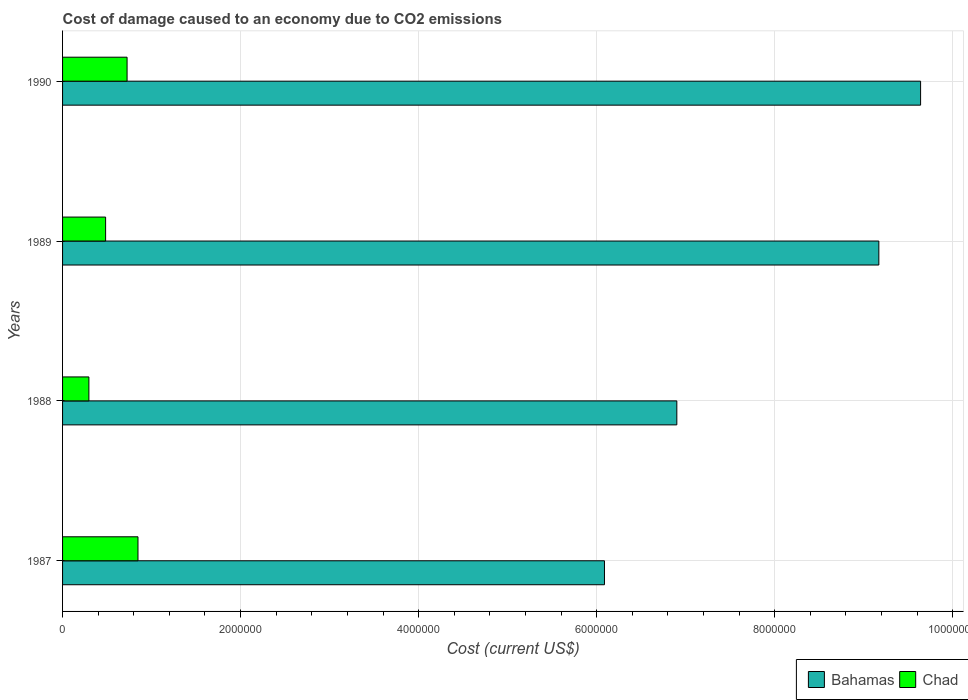How many groups of bars are there?
Give a very brief answer. 4. What is the label of the 4th group of bars from the top?
Keep it short and to the point. 1987. In how many cases, is the number of bars for a given year not equal to the number of legend labels?
Keep it short and to the point. 0. What is the cost of damage caused due to CO2 emissisons in Bahamas in 1988?
Offer a terse response. 6.90e+06. Across all years, what is the maximum cost of damage caused due to CO2 emissisons in Bahamas?
Offer a very short reply. 9.64e+06. Across all years, what is the minimum cost of damage caused due to CO2 emissisons in Chad?
Make the answer very short. 2.96e+05. In which year was the cost of damage caused due to CO2 emissisons in Bahamas minimum?
Your response must be concise. 1987. What is the total cost of damage caused due to CO2 emissisons in Bahamas in the graph?
Ensure brevity in your answer.  3.18e+07. What is the difference between the cost of damage caused due to CO2 emissisons in Chad in 1987 and that in 1989?
Ensure brevity in your answer.  3.64e+05. What is the difference between the cost of damage caused due to CO2 emissisons in Chad in 1987 and the cost of damage caused due to CO2 emissisons in Bahamas in 1988?
Provide a succinct answer. -6.05e+06. What is the average cost of damage caused due to CO2 emissisons in Chad per year?
Ensure brevity in your answer.  5.88e+05. In the year 1988, what is the difference between the cost of damage caused due to CO2 emissisons in Bahamas and cost of damage caused due to CO2 emissisons in Chad?
Your answer should be compact. 6.61e+06. What is the ratio of the cost of damage caused due to CO2 emissisons in Bahamas in 1988 to that in 1989?
Offer a terse response. 0.75. What is the difference between the highest and the second highest cost of damage caused due to CO2 emissisons in Bahamas?
Keep it short and to the point. 4.69e+05. What is the difference between the highest and the lowest cost of damage caused due to CO2 emissisons in Bahamas?
Keep it short and to the point. 3.55e+06. In how many years, is the cost of damage caused due to CO2 emissisons in Chad greater than the average cost of damage caused due to CO2 emissisons in Chad taken over all years?
Provide a short and direct response. 2. What does the 1st bar from the top in 1987 represents?
Offer a very short reply. Chad. What does the 1st bar from the bottom in 1990 represents?
Your response must be concise. Bahamas. What is the difference between two consecutive major ticks on the X-axis?
Your response must be concise. 2.00e+06. Does the graph contain any zero values?
Offer a very short reply. No. Where does the legend appear in the graph?
Make the answer very short. Bottom right. How are the legend labels stacked?
Offer a terse response. Horizontal. What is the title of the graph?
Keep it short and to the point. Cost of damage caused to an economy due to CO2 emissions. What is the label or title of the X-axis?
Offer a very short reply. Cost (current US$). What is the Cost (current US$) of Bahamas in 1987?
Provide a short and direct response. 6.09e+06. What is the Cost (current US$) of Chad in 1987?
Provide a short and direct response. 8.47e+05. What is the Cost (current US$) of Bahamas in 1988?
Offer a terse response. 6.90e+06. What is the Cost (current US$) in Chad in 1988?
Offer a very short reply. 2.96e+05. What is the Cost (current US$) of Bahamas in 1989?
Make the answer very short. 9.17e+06. What is the Cost (current US$) in Chad in 1989?
Give a very brief answer. 4.84e+05. What is the Cost (current US$) of Bahamas in 1990?
Ensure brevity in your answer.  9.64e+06. What is the Cost (current US$) of Chad in 1990?
Offer a very short reply. 7.25e+05. Across all years, what is the maximum Cost (current US$) in Bahamas?
Your answer should be compact. 9.64e+06. Across all years, what is the maximum Cost (current US$) of Chad?
Your answer should be compact. 8.47e+05. Across all years, what is the minimum Cost (current US$) of Bahamas?
Provide a short and direct response. 6.09e+06. Across all years, what is the minimum Cost (current US$) of Chad?
Your response must be concise. 2.96e+05. What is the total Cost (current US$) in Bahamas in the graph?
Your response must be concise. 3.18e+07. What is the total Cost (current US$) of Chad in the graph?
Give a very brief answer. 2.35e+06. What is the difference between the Cost (current US$) in Bahamas in 1987 and that in 1988?
Provide a succinct answer. -8.13e+05. What is the difference between the Cost (current US$) of Chad in 1987 and that in 1988?
Keep it short and to the point. 5.52e+05. What is the difference between the Cost (current US$) in Bahamas in 1987 and that in 1989?
Your answer should be very brief. -3.08e+06. What is the difference between the Cost (current US$) of Chad in 1987 and that in 1989?
Ensure brevity in your answer.  3.64e+05. What is the difference between the Cost (current US$) of Bahamas in 1987 and that in 1990?
Your answer should be very brief. -3.55e+06. What is the difference between the Cost (current US$) in Chad in 1987 and that in 1990?
Offer a terse response. 1.23e+05. What is the difference between the Cost (current US$) in Bahamas in 1988 and that in 1989?
Your answer should be very brief. -2.27e+06. What is the difference between the Cost (current US$) of Chad in 1988 and that in 1989?
Provide a succinct answer. -1.88e+05. What is the difference between the Cost (current US$) of Bahamas in 1988 and that in 1990?
Your response must be concise. -2.74e+06. What is the difference between the Cost (current US$) of Chad in 1988 and that in 1990?
Keep it short and to the point. -4.29e+05. What is the difference between the Cost (current US$) of Bahamas in 1989 and that in 1990?
Make the answer very short. -4.69e+05. What is the difference between the Cost (current US$) of Chad in 1989 and that in 1990?
Give a very brief answer. -2.41e+05. What is the difference between the Cost (current US$) in Bahamas in 1987 and the Cost (current US$) in Chad in 1988?
Provide a short and direct response. 5.79e+06. What is the difference between the Cost (current US$) of Bahamas in 1987 and the Cost (current US$) of Chad in 1989?
Provide a short and direct response. 5.60e+06. What is the difference between the Cost (current US$) in Bahamas in 1987 and the Cost (current US$) in Chad in 1990?
Make the answer very short. 5.36e+06. What is the difference between the Cost (current US$) of Bahamas in 1988 and the Cost (current US$) of Chad in 1989?
Your response must be concise. 6.42e+06. What is the difference between the Cost (current US$) in Bahamas in 1988 and the Cost (current US$) in Chad in 1990?
Your response must be concise. 6.18e+06. What is the difference between the Cost (current US$) of Bahamas in 1989 and the Cost (current US$) of Chad in 1990?
Your response must be concise. 8.45e+06. What is the average Cost (current US$) in Bahamas per year?
Give a very brief answer. 7.95e+06. What is the average Cost (current US$) in Chad per year?
Offer a very short reply. 5.88e+05. In the year 1987, what is the difference between the Cost (current US$) of Bahamas and Cost (current US$) of Chad?
Your answer should be compact. 5.24e+06. In the year 1988, what is the difference between the Cost (current US$) in Bahamas and Cost (current US$) in Chad?
Make the answer very short. 6.61e+06. In the year 1989, what is the difference between the Cost (current US$) of Bahamas and Cost (current US$) of Chad?
Ensure brevity in your answer.  8.69e+06. In the year 1990, what is the difference between the Cost (current US$) in Bahamas and Cost (current US$) in Chad?
Give a very brief answer. 8.92e+06. What is the ratio of the Cost (current US$) of Bahamas in 1987 to that in 1988?
Your answer should be compact. 0.88. What is the ratio of the Cost (current US$) in Chad in 1987 to that in 1988?
Provide a succinct answer. 2.86. What is the ratio of the Cost (current US$) in Bahamas in 1987 to that in 1989?
Ensure brevity in your answer.  0.66. What is the ratio of the Cost (current US$) in Chad in 1987 to that in 1989?
Make the answer very short. 1.75. What is the ratio of the Cost (current US$) of Bahamas in 1987 to that in 1990?
Ensure brevity in your answer.  0.63. What is the ratio of the Cost (current US$) in Chad in 1987 to that in 1990?
Your answer should be compact. 1.17. What is the ratio of the Cost (current US$) in Bahamas in 1988 to that in 1989?
Give a very brief answer. 0.75. What is the ratio of the Cost (current US$) in Chad in 1988 to that in 1989?
Make the answer very short. 0.61. What is the ratio of the Cost (current US$) of Bahamas in 1988 to that in 1990?
Provide a short and direct response. 0.72. What is the ratio of the Cost (current US$) in Chad in 1988 to that in 1990?
Make the answer very short. 0.41. What is the ratio of the Cost (current US$) in Bahamas in 1989 to that in 1990?
Give a very brief answer. 0.95. What is the ratio of the Cost (current US$) of Chad in 1989 to that in 1990?
Provide a succinct answer. 0.67. What is the difference between the highest and the second highest Cost (current US$) of Bahamas?
Your answer should be compact. 4.69e+05. What is the difference between the highest and the second highest Cost (current US$) in Chad?
Offer a terse response. 1.23e+05. What is the difference between the highest and the lowest Cost (current US$) in Bahamas?
Your answer should be compact. 3.55e+06. What is the difference between the highest and the lowest Cost (current US$) in Chad?
Offer a terse response. 5.52e+05. 